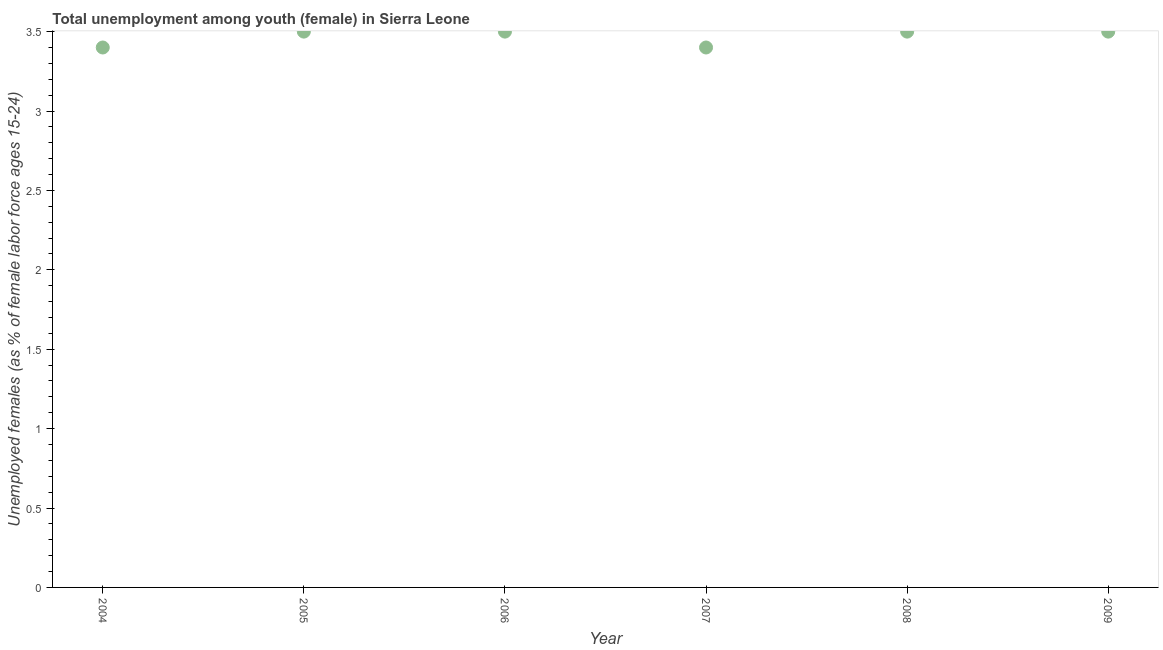Across all years, what is the maximum unemployed female youth population?
Your answer should be compact. 3.5. Across all years, what is the minimum unemployed female youth population?
Provide a short and direct response. 3.4. What is the sum of the unemployed female youth population?
Your response must be concise. 20.8. What is the difference between the unemployed female youth population in 2004 and 2008?
Your response must be concise. -0.1. What is the average unemployed female youth population per year?
Offer a very short reply. 3.47. In how many years, is the unemployed female youth population greater than 3.3 %?
Your answer should be compact. 6. Do a majority of the years between 2009 and 2006 (inclusive) have unemployed female youth population greater than 2.3 %?
Provide a short and direct response. Yes. What is the ratio of the unemployed female youth population in 2008 to that in 2009?
Ensure brevity in your answer.  1. Is the unemployed female youth population in 2006 less than that in 2007?
Your answer should be very brief. No. What is the difference between the highest and the second highest unemployed female youth population?
Your answer should be compact. 0. What is the difference between the highest and the lowest unemployed female youth population?
Your response must be concise. 0.1. Does the unemployed female youth population monotonically increase over the years?
Provide a succinct answer. No. How many dotlines are there?
Give a very brief answer. 1. How many years are there in the graph?
Ensure brevity in your answer.  6. Are the values on the major ticks of Y-axis written in scientific E-notation?
Ensure brevity in your answer.  No. What is the title of the graph?
Offer a very short reply. Total unemployment among youth (female) in Sierra Leone. What is the label or title of the Y-axis?
Your response must be concise. Unemployed females (as % of female labor force ages 15-24). What is the Unemployed females (as % of female labor force ages 15-24) in 2004?
Keep it short and to the point. 3.4. What is the Unemployed females (as % of female labor force ages 15-24) in 2007?
Offer a terse response. 3.4. What is the Unemployed females (as % of female labor force ages 15-24) in 2009?
Your response must be concise. 3.5. What is the difference between the Unemployed females (as % of female labor force ages 15-24) in 2004 and 2005?
Provide a short and direct response. -0.1. What is the difference between the Unemployed females (as % of female labor force ages 15-24) in 2004 and 2007?
Offer a terse response. 0. What is the difference between the Unemployed females (as % of female labor force ages 15-24) in 2004 and 2008?
Provide a short and direct response. -0.1. What is the difference between the Unemployed females (as % of female labor force ages 15-24) in 2004 and 2009?
Your answer should be compact. -0.1. What is the difference between the Unemployed females (as % of female labor force ages 15-24) in 2005 and 2007?
Provide a succinct answer. 0.1. What is the difference between the Unemployed females (as % of female labor force ages 15-24) in 2005 and 2008?
Your response must be concise. 0. What is the difference between the Unemployed females (as % of female labor force ages 15-24) in 2005 and 2009?
Your response must be concise. 0. What is the difference between the Unemployed females (as % of female labor force ages 15-24) in 2006 and 2008?
Your response must be concise. 0. What is the difference between the Unemployed females (as % of female labor force ages 15-24) in 2007 and 2008?
Provide a succinct answer. -0.1. What is the difference between the Unemployed females (as % of female labor force ages 15-24) in 2008 and 2009?
Ensure brevity in your answer.  0. What is the ratio of the Unemployed females (as % of female labor force ages 15-24) in 2004 to that in 2006?
Offer a very short reply. 0.97. What is the ratio of the Unemployed females (as % of female labor force ages 15-24) in 2004 to that in 2007?
Keep it short and to the point. 1. What is the ratio of the Unemployed females (as % of female labor force ages 15-24) in 2004 to that in 2008?
Make the answer very short. 0.97. What is the ratio of the Unemployed females (as % of female labor force ages 15-24) in 2005 to that in 2006?
Give a very brief answer. 1. What is the ratio of the Unemployed females (as % of female labor force ages 15-24) in 2005 to that in 2007?
Give a very brief answer. 1.03. What is the ratio of the Unemployed females (as % of female labor force ages 15-24) in 2005 to that in 2008?
Provide a succinct answer. 1. What is the ratio of the Unemployed females (as % of female labor force ages 15-24) in 2006 to that in 2008?
Give a very brief answer. 1. What is the ratio of the Unemployed females (as % of female labor force ages 15-24) in 2007 to that in 2008?
Ensure brevity in your answer.  0.97. What is the ratio of the Unemployed females (as % of female labor force ages 15-24) in 2008 to that in 2009?
Provide a short and direct response. 1. 